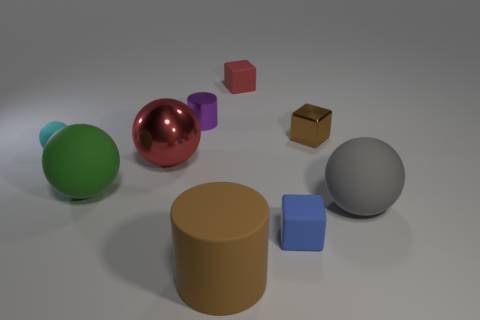Subtract all blocks. How many objects are left? 6 Subtract 2 balls. How many balls are left? 2 Subtract all blue cubes. Subtract all gray cylinders. How many cubes are left? 2 Subtract all green cylinders. How many yellow cubes are left? 0 Subtract all tiny cyan shiny blocks. Subtract all brown rubber cylinders. How many objects are left? 8 Add 6 matte spheres. How many matte spheres are left? 9 Add 9 shiny cubes. How many shiny cubes exist? 10 Subtract all blue cubes. How many cubes are left? 2 Subtract all small blue rubber blocks. How many blocks are left? 2 Subtract 0 blue balls. How many objects are left? 9 